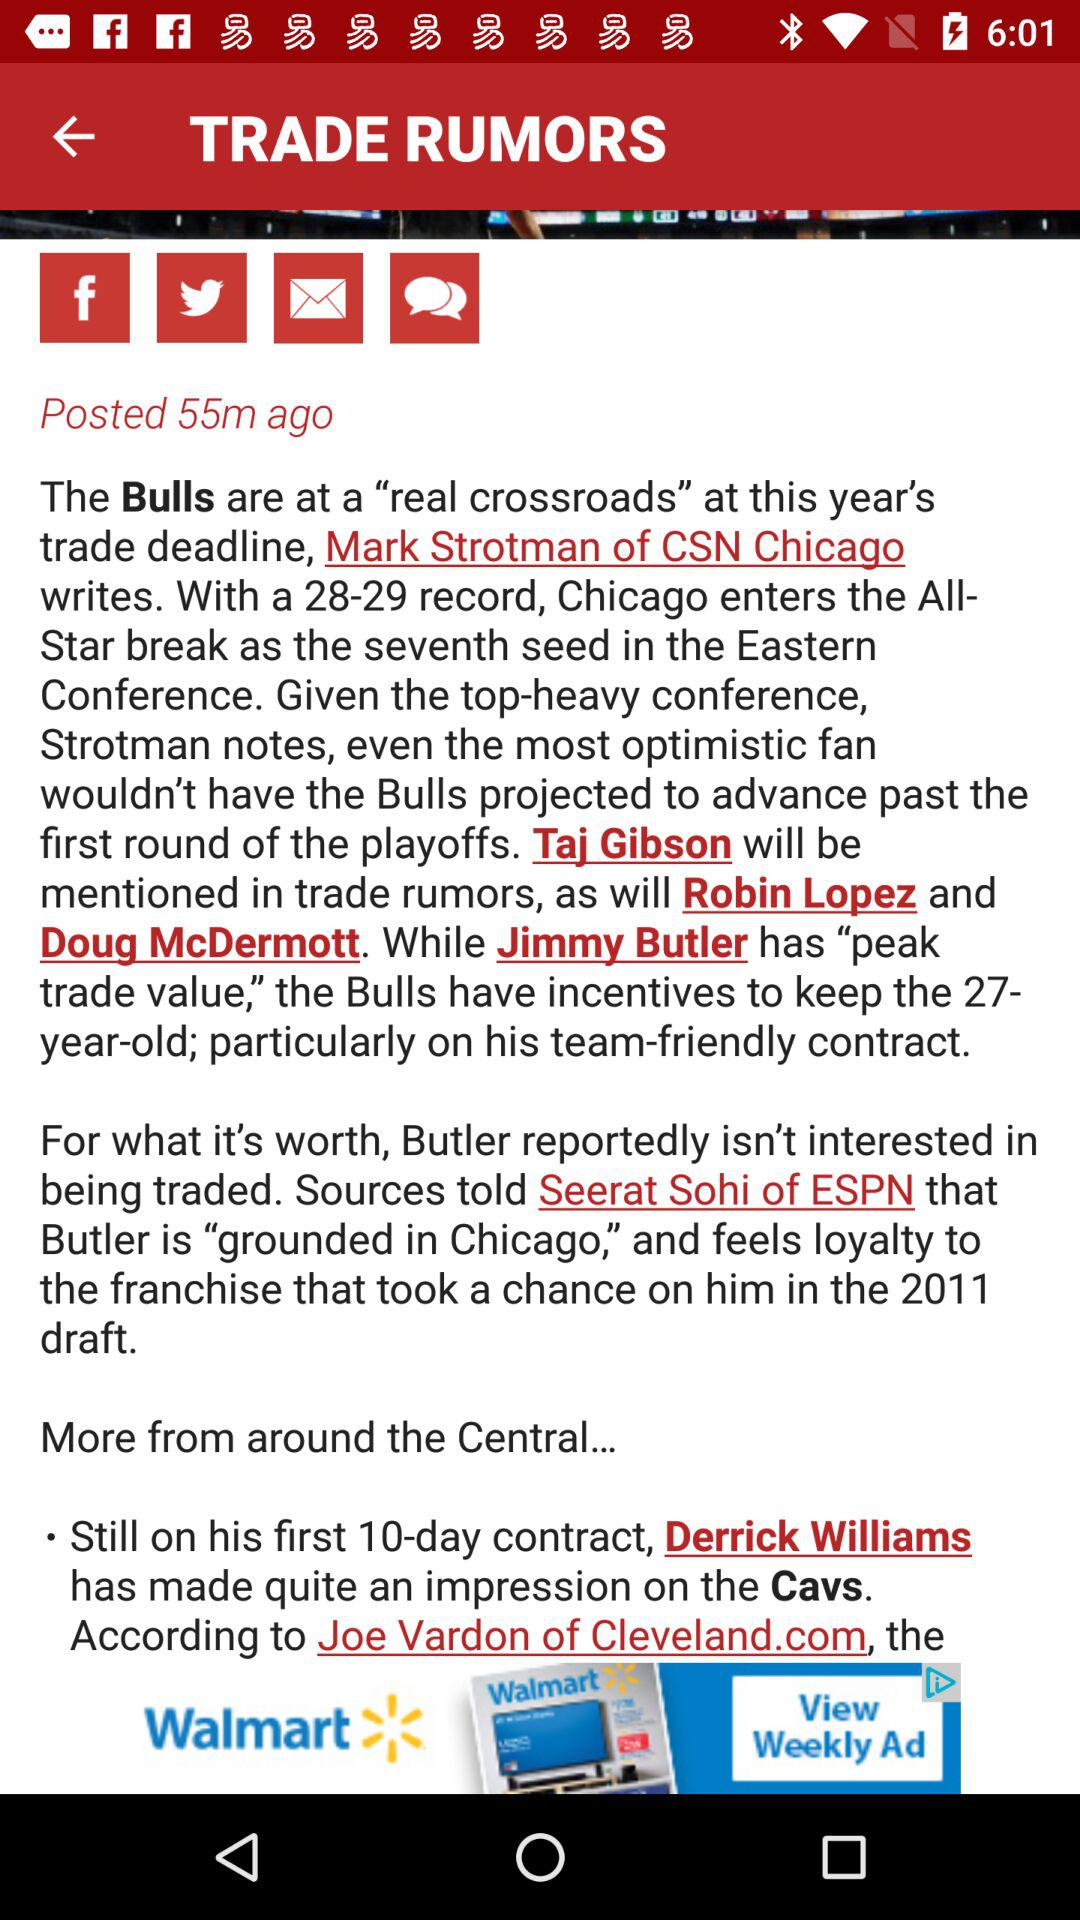What is the posted time of the article? The posted time of the article is 55 minutes ago. 